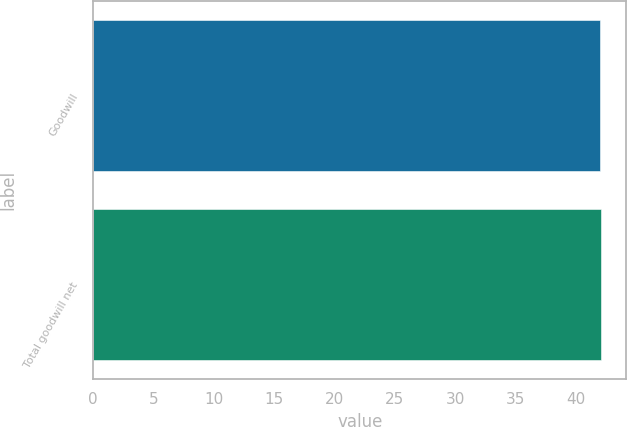<chart> <loc_0><loc_0><loc_500><loc_500><bar_chart><fcel>Goodwill<fcel>Total goodwill net<nl><fcel>42<fcel>42.1<nl></chart> 